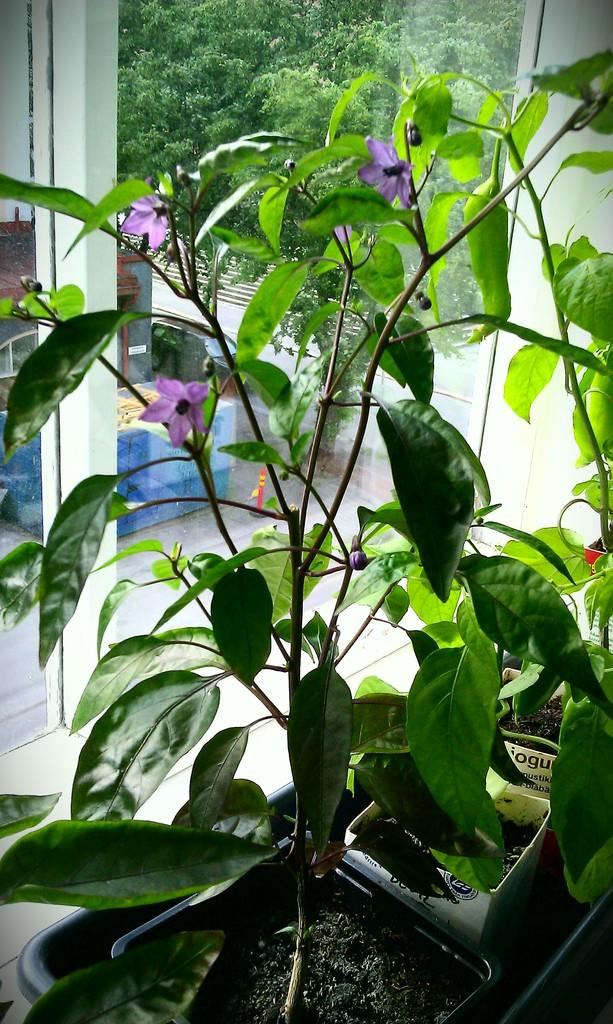What type of flowers can be seen in the image? There are purple color flowers in the image. Where are the flowers located? The flowers are on plants. What can be seen through the glass window in the image? There is a building and many trees visible through the window. How many pizzas are being served on the wooden table in the image? There is no wooden table or pizzas present in the image. Can you see a duck swimming in the nearby pond through the window? There is no pond or duck visible through the window in the image. 